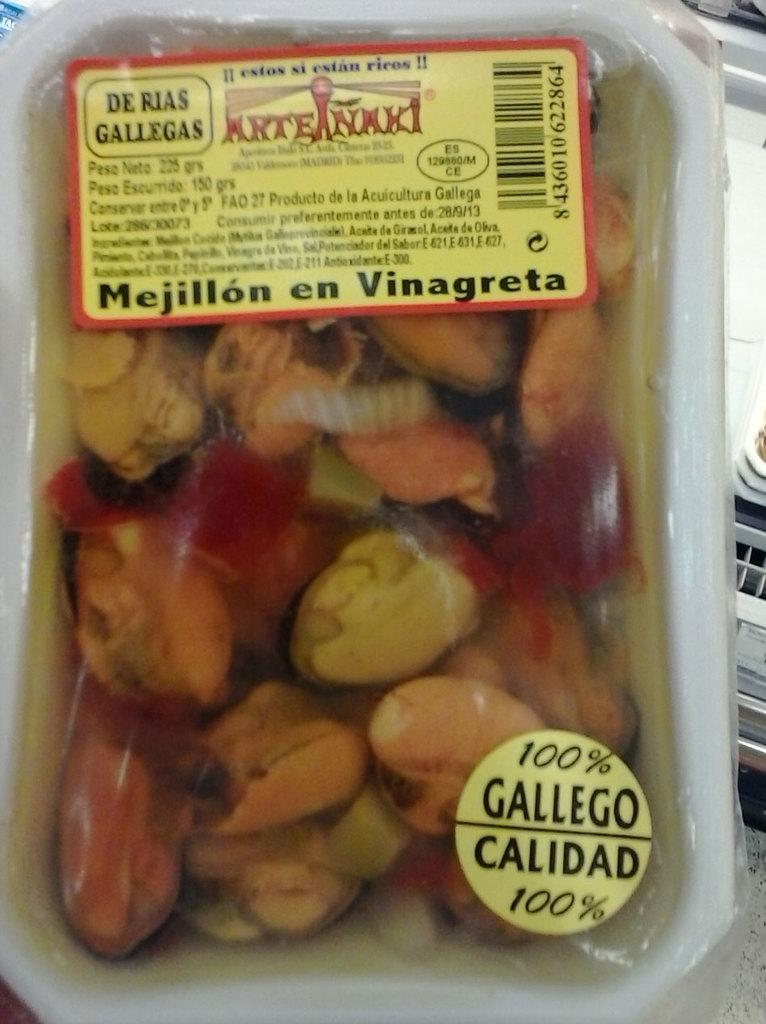What type of items can be seen in the image? There are packed foods in the image. Can you describe the appearance of the packed foods? The packed foods appear to be in containers or wrappers. How many packed foods are visible in the image? The exact number of packed foods cannot be determined from the image, but there are multiple items visible. What type of muscle is being exercised by the train in the image? There is no train present in the image, and therefore no muscle exercise can be observed. 